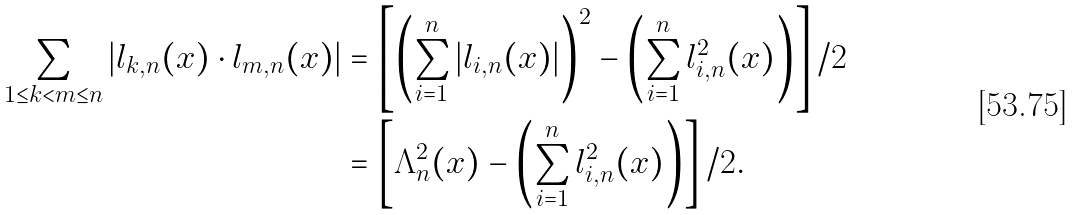Convert formula to latex. <formula><loc_0><loc_0><loc_500><loc_500>\sum _ { 1 \leq k < m \leq n } { \left | l _ { k , n } ( x ) \cdot l _ { m , n } ( x ) \right | } & = \left [ \left ( \sum ^ { n } _ { i = 1 } { \left | l _ { i , n } ( x ) \right | } \right ) ^ { 2 } - \left ( \sum ^ { n } _ { i = 1 } { l ^ { 2 } _ { i , n } ( x ) } \right ) \right ] / 2 \\ & = \left [ \Lambda ^ { 2 } _ { n } ( x ) - \left ( \sum ^ { n } _ { i = 1 } { l ^ { 2 } _ { i , n } ( x ) } \right ) \right ] / 2 .</formula> 